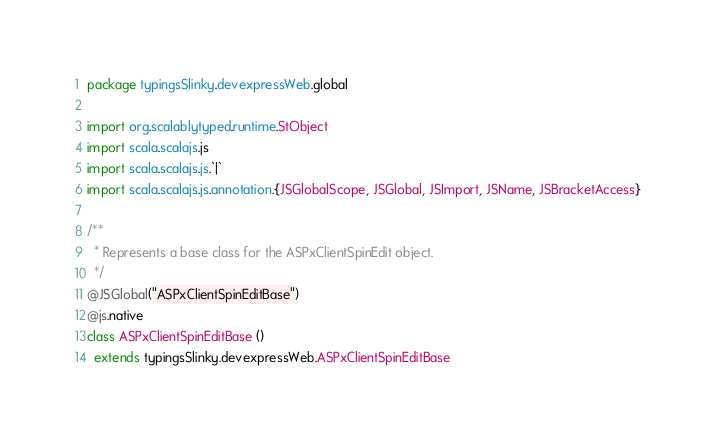<code> <loc_0><loc_0><loc_500><loc_500><_Scala_>package typingsSlinky.devexpressWeb.global

import org.scalablytyped.runtime.StObject
import scala.scalajs.js
import scala.scalajs.js.`|`
import scala.scalajs.js.annotation.{JSGlobalScope, JSGlobal, JSImport, JSName, JSBracketAccess}

/**
  * Represents a base class for the ASPxClientSpinEdit object.
  */
@JSGlobal("ASPxClientSpinEditBase")
@js.native
class ASPxClientSpinEditBase ()
  extends typingsSlinky.devexpressWeb.ASPxClientSpinEditBase
</code> 